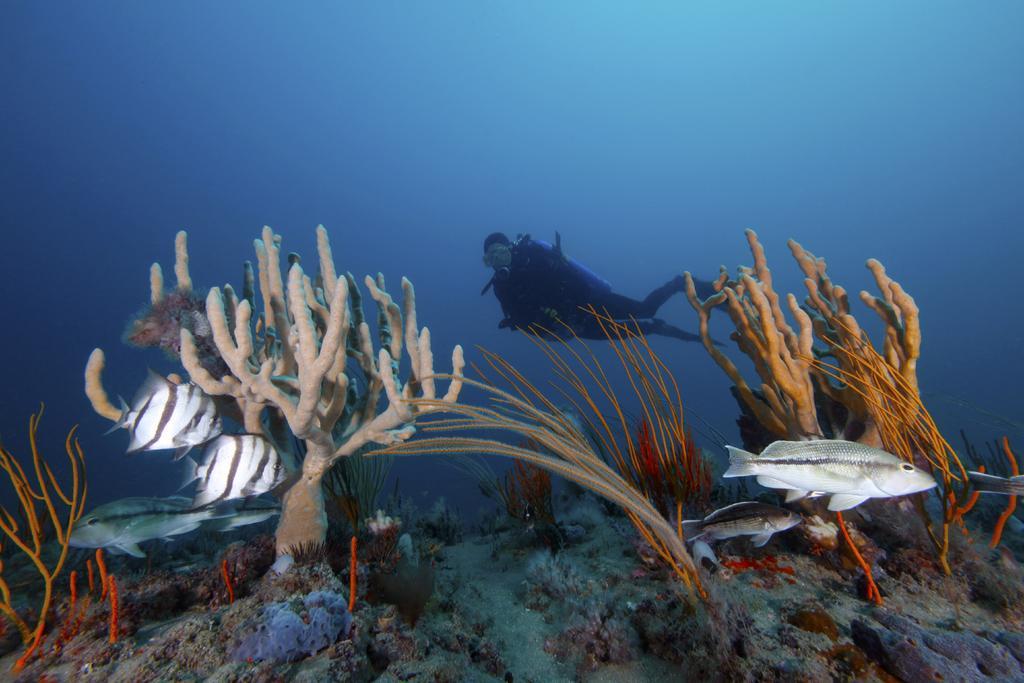In one or two sentences, can you explain what this image depicts? In this image we can see a person diving into water and there are water plants and we can see fishes. 